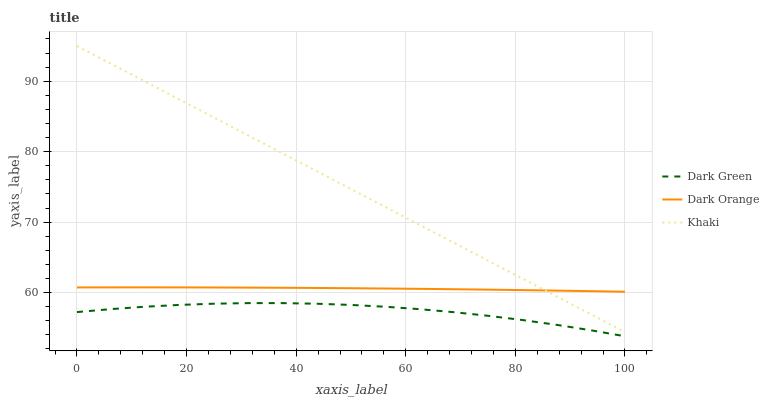Does Dark Green have the minimum area under the curve?
Answer yes or no. Yes. Does Khaki have the maximum area under the curve?
Answer yes or no. Yes. Does Khaki have the minimum area under the curve?
Answer yes or no. No. Does Dark Green have the maximum area under the curve?
Answer yes or no. No. Is Khaki the smoothest?
Answer yes or no. Yes. Is Dark Green the roughest?
Answer yes or no. Yes. Is Dark Green the smoothest?
Answer yes or no. No. Is Khaki the roughest?
Answer yes or no. No. Does Dark Green have the lowest value?
Answer yes or no. Yes. Does Khaki have the lowest value?
Answer yes or no. No. Does Khaki have the highest value?
Answer yes or no. Yes. Does Dark Green have the highest value?
Answer yes or no. No. Is Dark Green less than Khaki?
Answer yes or no. Yes. Is Dark Orange greater than Dark Green?
Answer yes or no. Yes. Does Dark Orange intersect Khaki?
Answer yes or no. Yes. Is Dark Orange less than Khaki?
Answer yes or no. No. Is Dark Orange greater than Khaki?
Answer yes or no. No. Does Dark Green intersect Khaki?
Answer yes or no. No. 